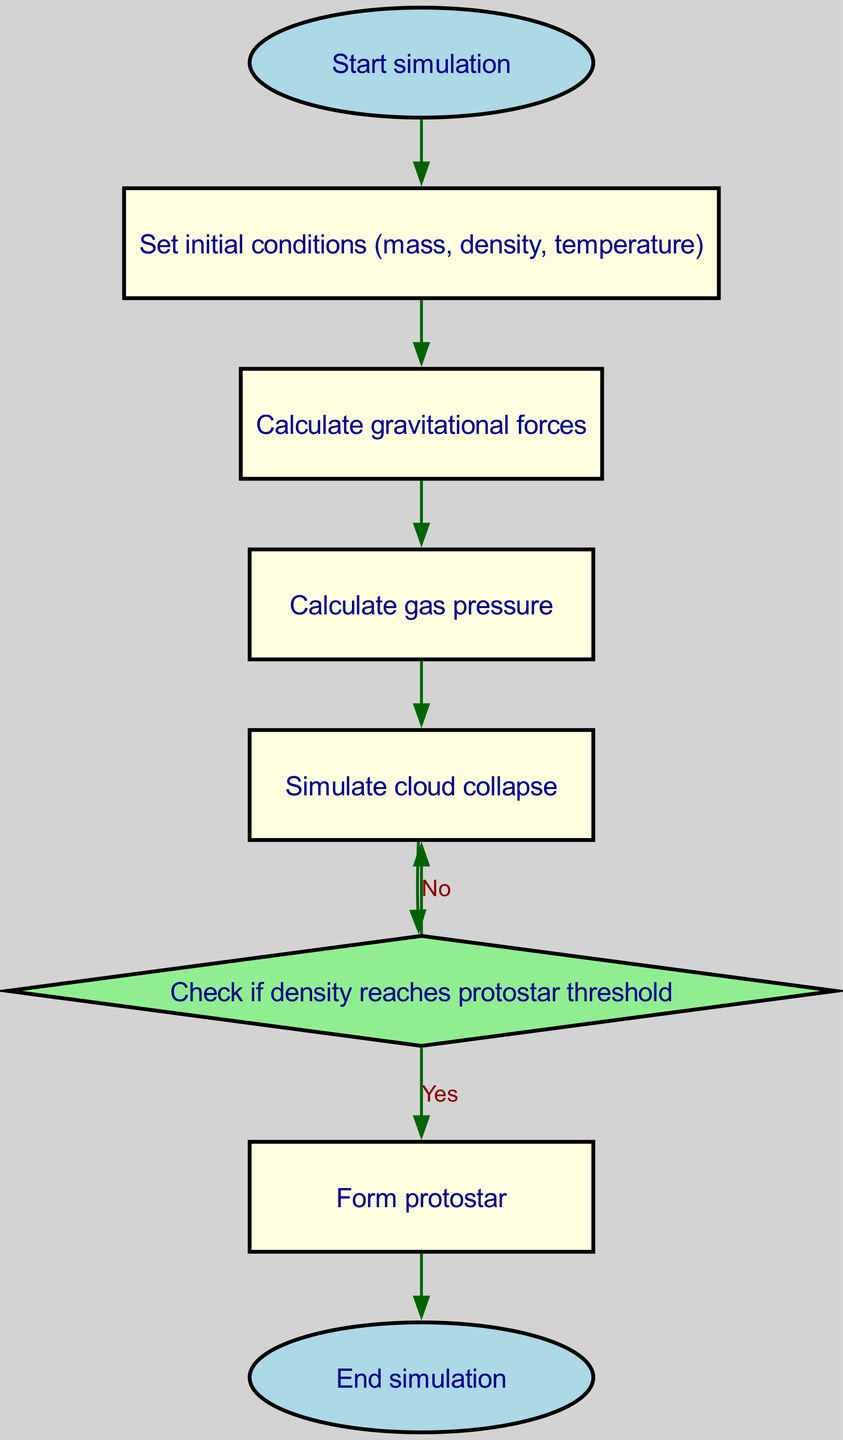What is the first step in the simulation? The flowchart indicates that the first step is "Start simulation," which is set as the initial node in the diagram.
Answer: Start simulation How many nodes are present in the flowchart? The flowchart contains eight nodes in total, representing different steps in the simulation process.
Answer: Eight What action follows after calculating gas pressure? After calculating gas pressure, the next action depicted in the flowchart is "Simulate cloud collapse." This follows directly based on the connectivity of the nodes.
Answer: Simulate cloud collapse What happens if the density does not reach the protostar threshold? If the density does not reach the protostar threshold, the flowchart shows that the process loops back to "Simulate cloud collapse," indicating the need for further simulation until the threshold is met.
Answer: Simulate cloud collapse What shape is used for the "density check" node? The node labeled "Check if density reaches protostar threshold" is represented as a diamond shape, which typically signifies a decision point in a flowchart.
Answer: Diamond 